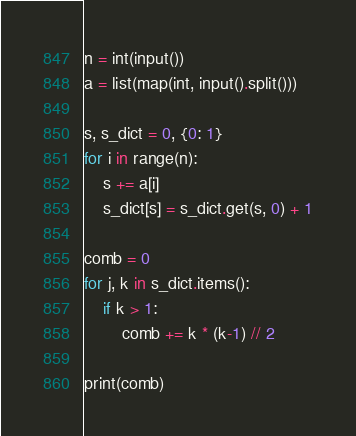Convert code to text. <code><loc_0><loc_0><loc_500><loc_500><_Python_>n = int(input())
a = list(map(int, input().split()))

s, s_dict = 0, {0: 1}
for i in range(n):
    s += a[i]
    s_dict[s] = s_dict.get(s, 0) + 1

comb = 0
for j, k in s_dict.items():
    if k > 1:
        comb += k * (k-1) // 2

print(comb)
</code> 